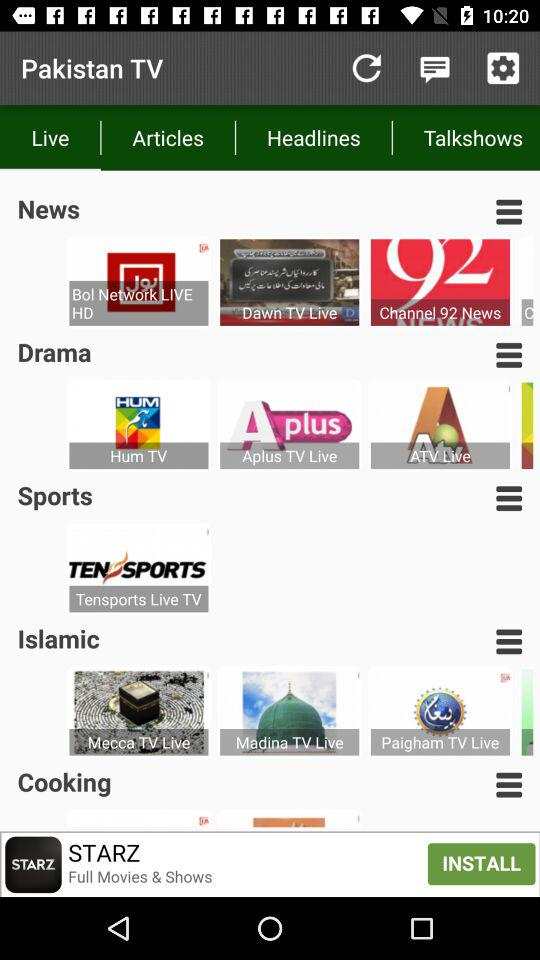What are the different types of media channel categories shown? The different types of media channel categories are "News", "Drama", "Sports", "Islamic", and "Cooking". 